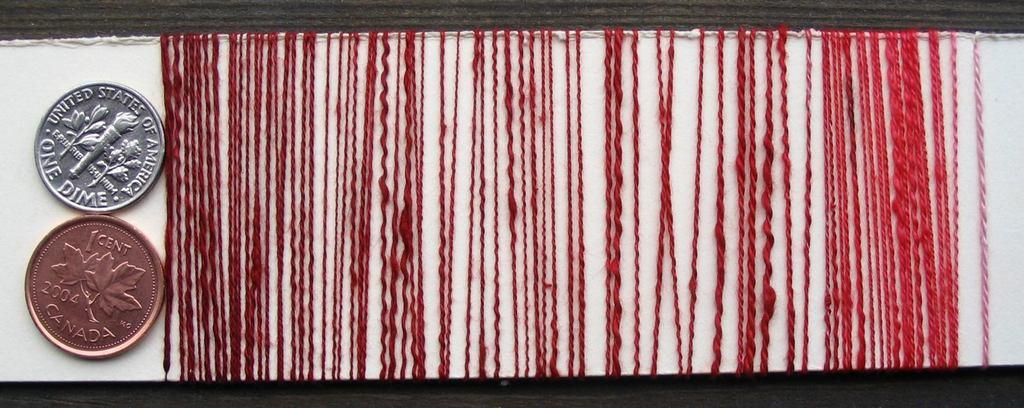What objects can be seen in the image? There are coins in the image. What else is present on the table in the image? There is a thread on the table in the image. What type of string is being used to play volleyball in the image? There is no string or volleyball present in the image; it only features coins and a thread on the table. 